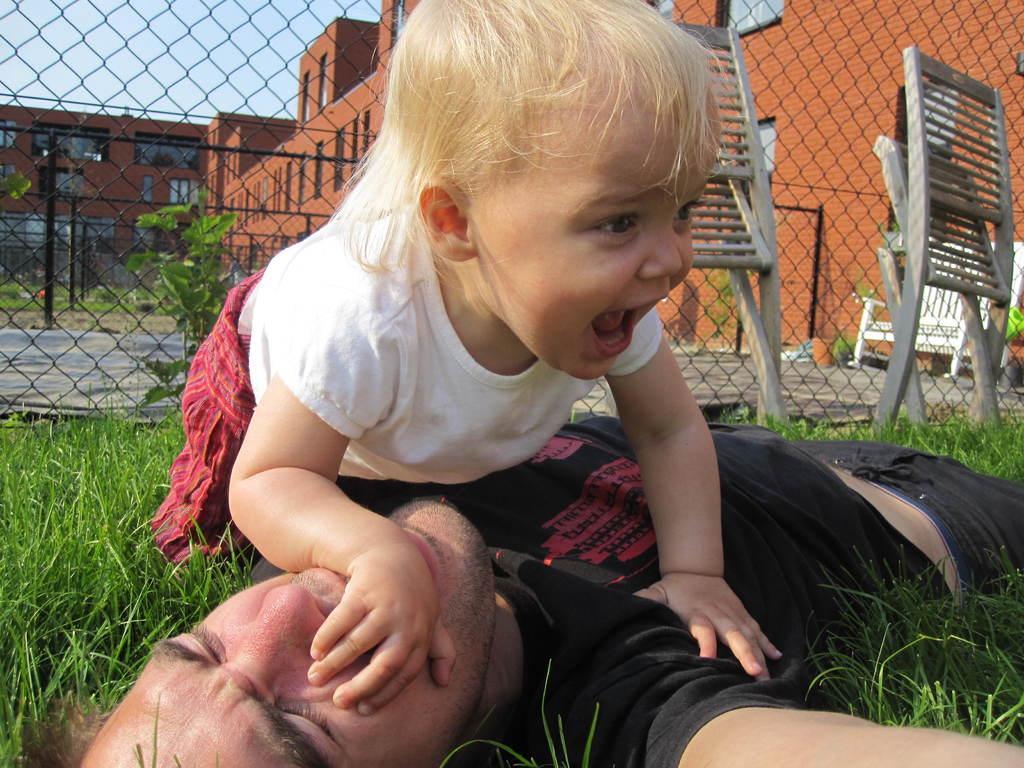Describe this image in one or two sentences. In this image there is a man laying, on a grassland on above him there is a girl, in the background there are two chairs fencing buildings and the sky. 